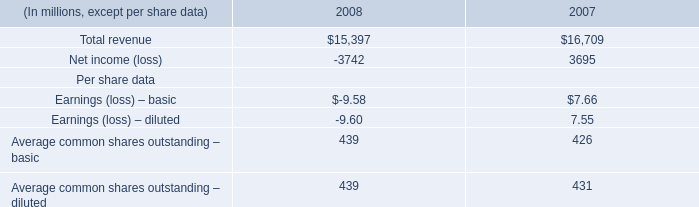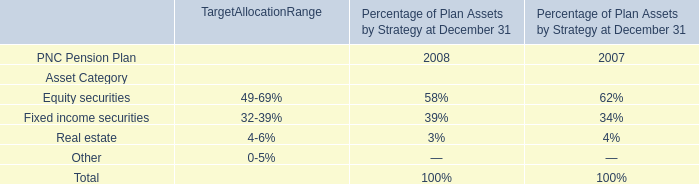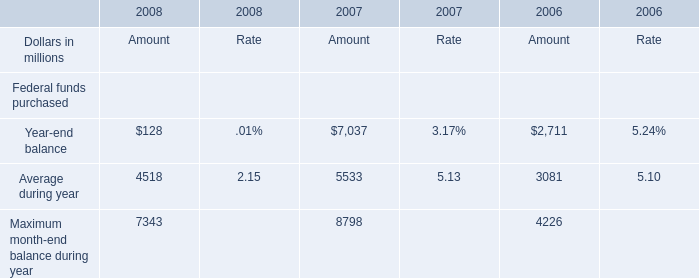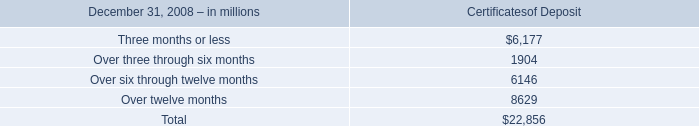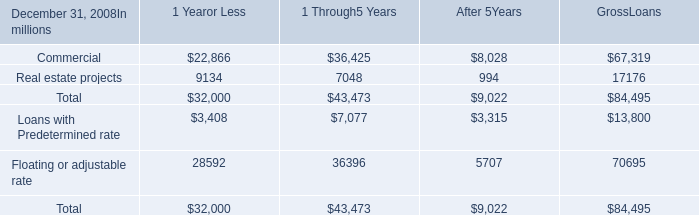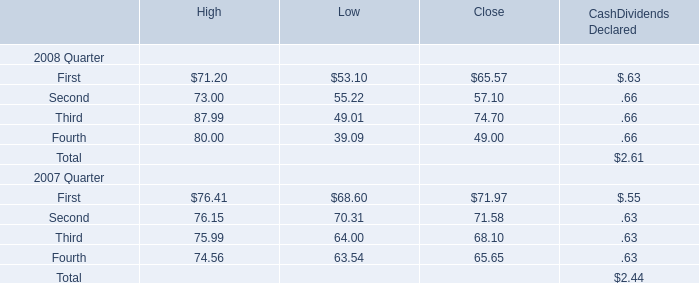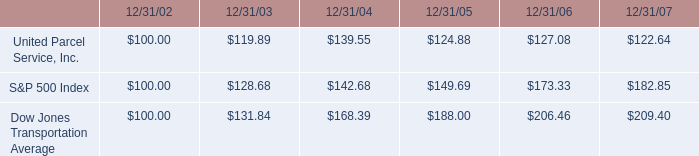What is the sum of Year-end balance, Average during year and Maximum month-end balance during year in 2008? (in million) 
Computations: ((128 + 4518) + 7343)
Answer: 11989.0. 